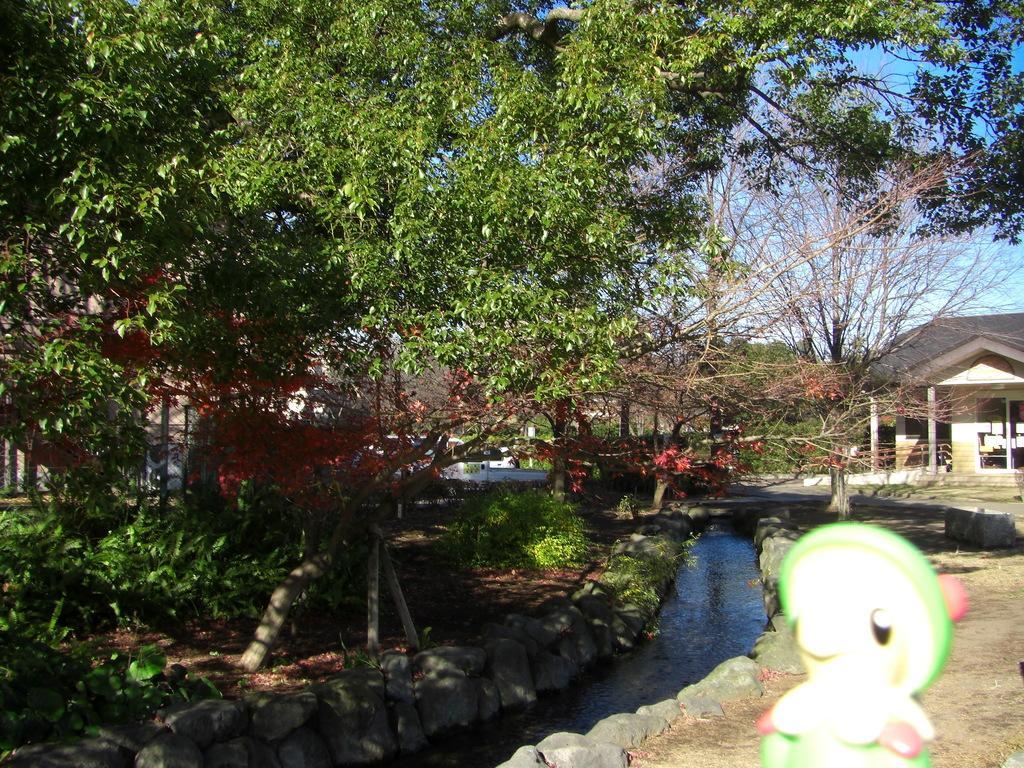In one or two sentences, can you explain what this image depicts? In this image we can see buildings, trees, bushes, shredded leaves on the ground, stones, canal and sky with clouds. 